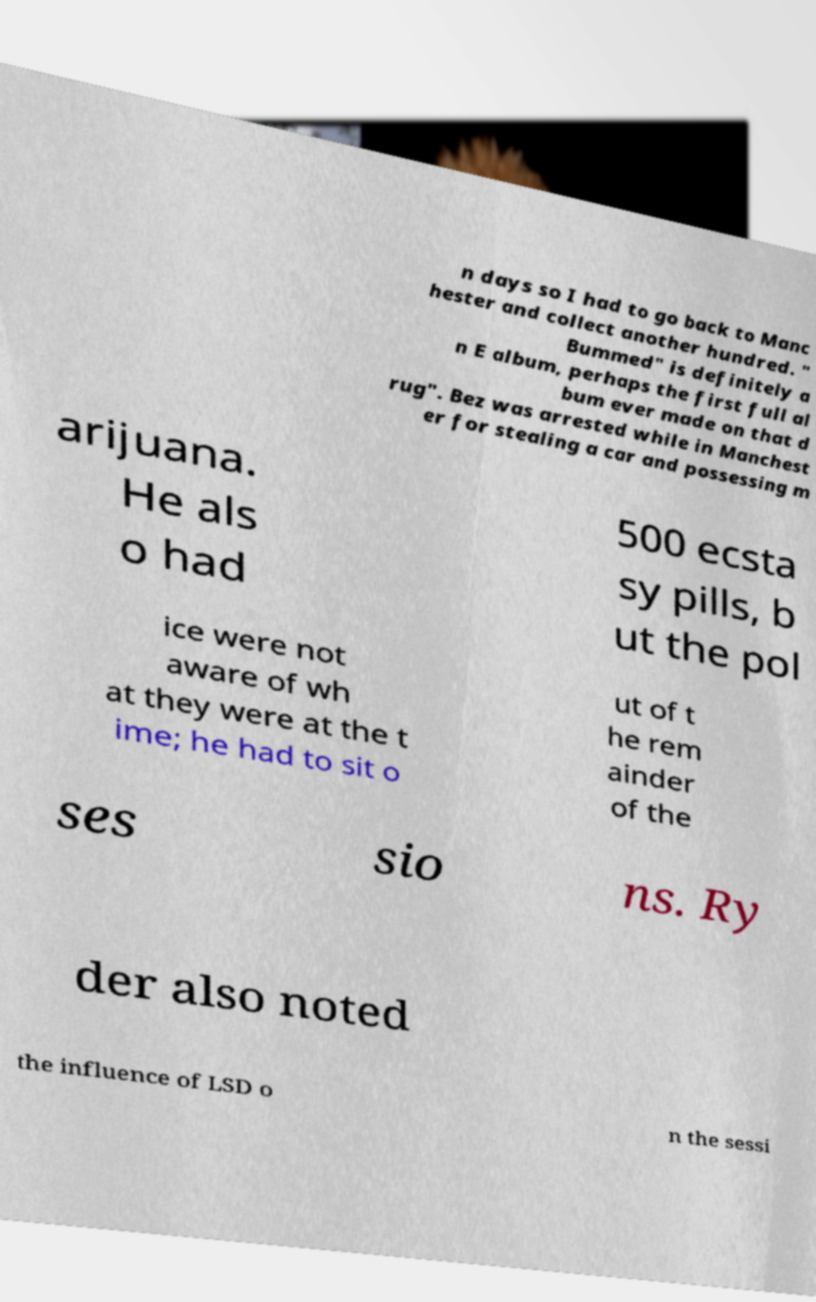Can you accurately transcribe the text from the provided image for me? n days so I had to go back to Manc hester and collect another hundred. " Bummed" is definitely a n E album, perhaps the first full al bum ever made on that d rug". Bez was arrested while in Manchest er for stealing a car and possessing m arijuana. He als o had 500 ecsta sy pills, b ut the pol ice were not aware of wh at they were at the t ime; he had to sit o ut of t he rem ainder of the ses sio ns. Ry der also noted the influence of LSD o n the sessi 